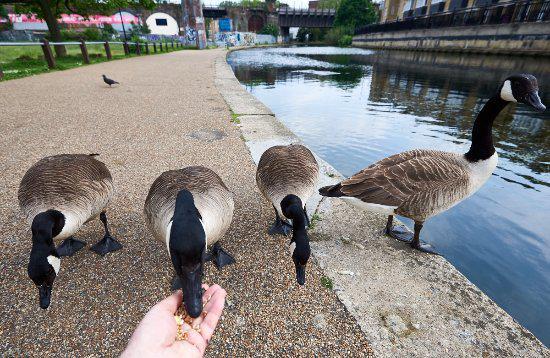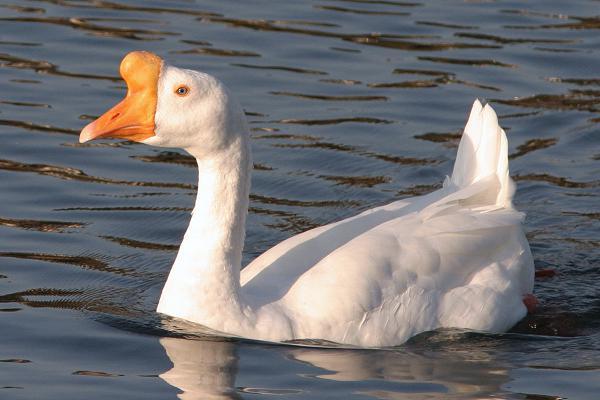The first image is the image on the left, the second image is the image on the right. For the images shown, is this caption "there is a single goose with a knob on it's forehead" true? Answer yes or no. Yes. The first image is the image on the left, the second image is the image on the right. Assess this claim about the two images: "A goose has a horn-like projection above its beak, and the only bird in the foreground of the image on the right is white.". Correct or not? Answer yes or no. Yes. 